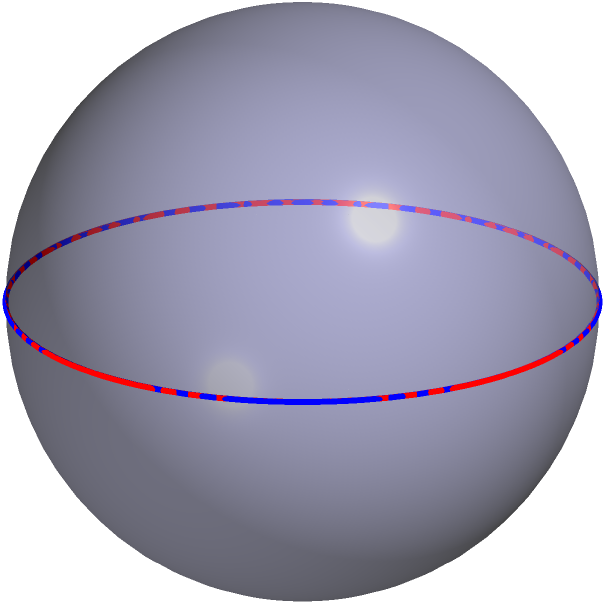In elliptic geometry, as shown on this sphere, how many times do the two great circles (represented by the red and blue lines) intersect? How does this relate to parallel lines in Euclidean geometry? To answer this question, let's break it down step-by-step:

1. In elliptic geometry, straight lines are represented by great circles on a sphere. A great circle is the intersection of a sphere with a plane that passes through the center of the sphere.

2. In the diagram, we see two great circles: one in red (passing through points A and B) and one in blue (passing through points C and D).

3. These great circles intersect at two points: one visible on the front of the sphere, and one on the back (not visible in this 2D projection).

4. This is fundamentally different from Euclidean geometry, where parallel lines never intersect.

5. In Euclidean geometry, two distinct lines in a plane are either:
   a) Intersecting at one point, or
   b) Parallel (never intersecting)

6. However, in elliptic geometry on a sphere:
   a) Any two great circles always intersect at exactly two points
   b) There are no parallel lines

7. This concept is similar to how in Apex Legends, Mirage's decoys can appear to come from different directions but ultimately converge at a single point, much like these great circles intersecting on the sphere.

Therefore, the two great circles intersect twice, which is fundamentally different from parallel lines in Euclidean geometry that never intersect.
Answer: Twice; parallel lines don't exist in elliptic geometry. 